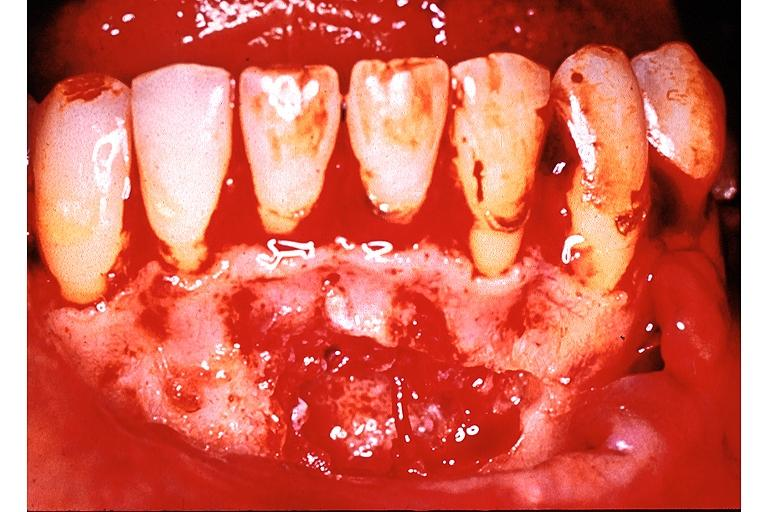where is this?
Answer the question using a single word or phrase. Oral 